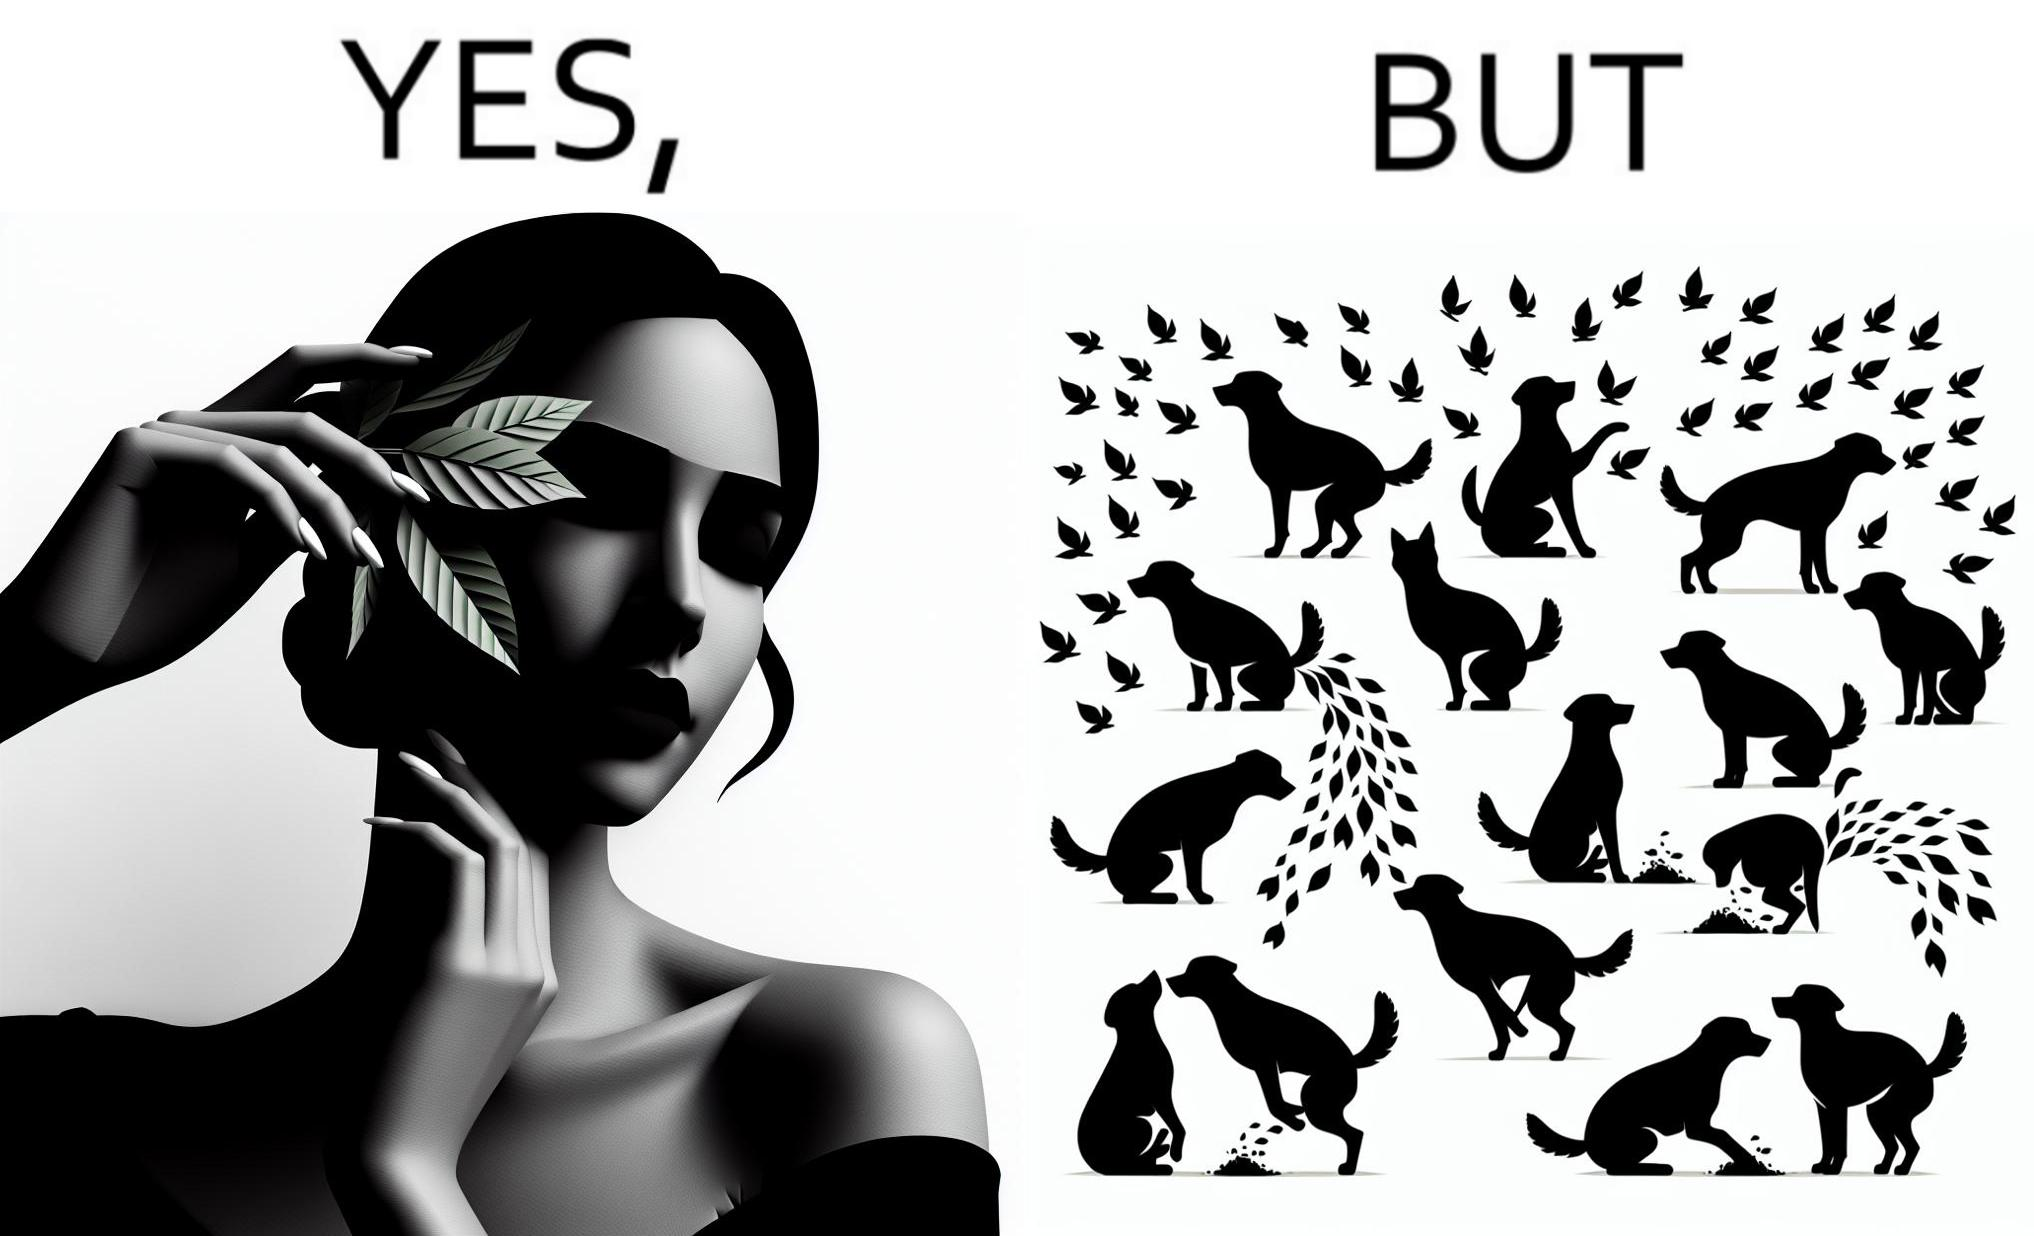What is shown in this image? The images are funny since it show a woman holding a leaf over half of her face for a good photo but unknown to her is thale fact the same leaf might have been defecated or urinated upon by dogs and other wild animals 